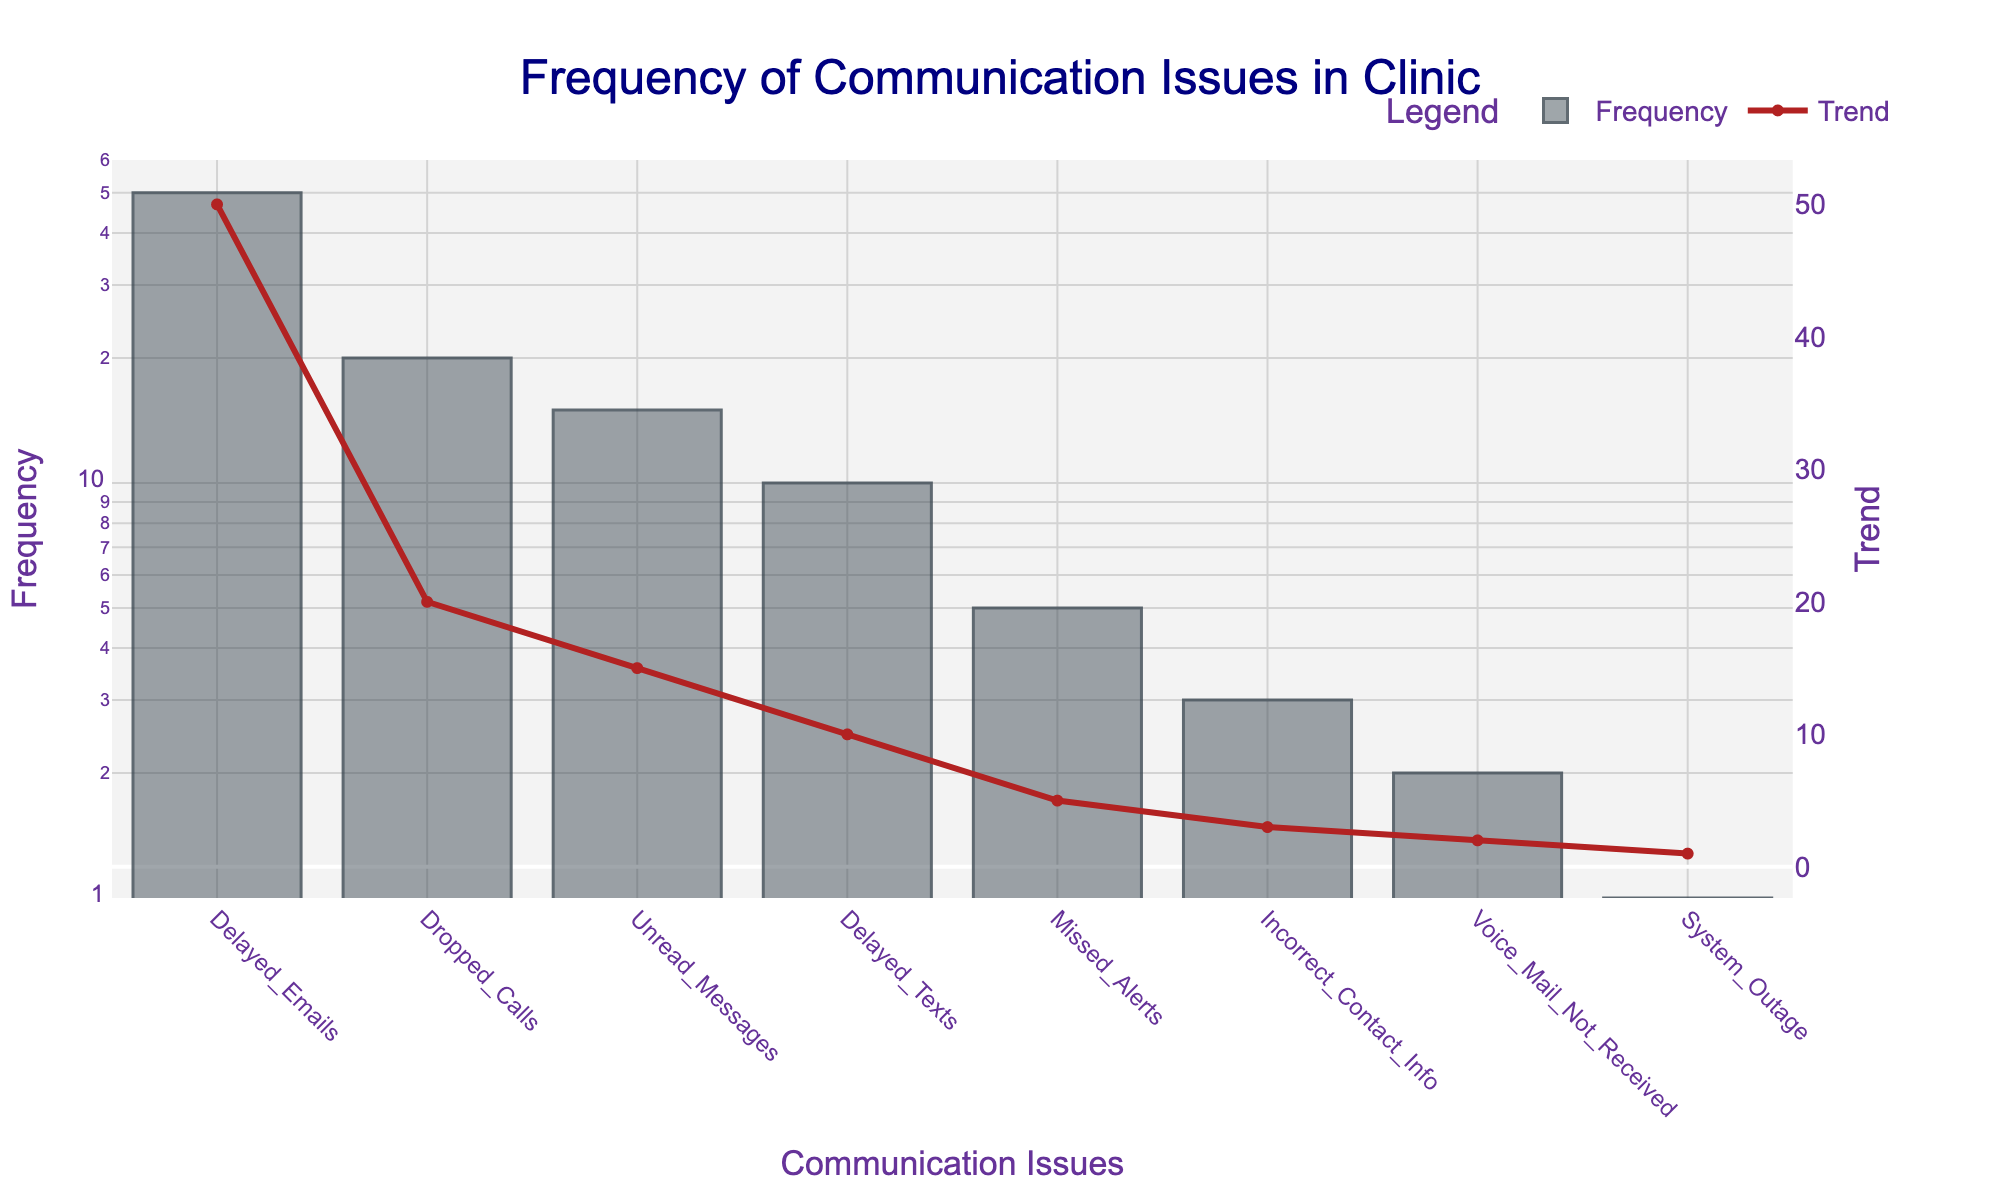What is the title of the plot? The title of a plot is usually found at the top and provides an overview of what the plot represents. In this plot, the title is 'Frequency of Communication Issues in Clinic'.
Answer: Frequency of Communication Issues in Clinic Which communication issue has the highest frequency? To find the communication issue with the highest frequency, look at the bar with the greatest height on the y-axis or the highest value on the line plot. In this plot, 'Delayed Emails' is the highest.
Answer: Delayed Emails What is the frequency of 'Unread Messages'? Locate the bar corresponding to 'Unread Messages' and identify its height on the y-axis. The figure indicates that 'Unread Messages' has a frequency of 15.
Answer: 15 Which communication issue has the lowest frequency, and what is its value? To identify the issue with the lowest frequency, find the smallest bar or the lowest point on the line plot. 'System_Outage' has the lowest frequency, which is 1.
Answer: System_Outage, 1 How many communication issues have a frequency greater than 10? Examine the heights of the bars and count the number of bars with a y-value greater than 10. The issues that meet this criterion are 'Dropped Calls', 'Delayed Emails', and 'Delayed Texts', making a total of 3.
Answer: 3 What is the log scale range of the y-axis? The log scale of the y-axis ranges from 0 to approximately the log of 1.2 times the highest frequency in the data. Here, the highest frequency is 50, so the range is from 0 to about log10(50*1.2). Logarithm of 60 approximately equals 1.78.
Answer: 0 to 1.78 Which communication issue is second most frequent, and what is its frequency? To determine the second most frequent issue, find the second highest bar or point on the line plot. In this plot, 'Dropped Calls' is the second most frequent issue with a frequency of 20.
Answer: Dropped Calls, 20 What is the average frequency of all the communication issues? First, sum up all the frequencies (20 + 50 + 15 + 2 + 3 + 5 + 1 + 10 = 106). Then divide by the number of issues (8). The average frequency is 106/8 = 13.25.
Answer: 13.25 How many issues have a frequency less than 5? Count the bars or points on the line plot with y-values less than 5. These issues are 'Voice Mail Not Received', 'Incorrect Contact Info', 'Missed Alerts', and 'System Outage', making a total of 4.
Answer: 4 Which issue has a greater frequency: 'Missed Alerts' or 'Delayed Texts'? Compare the heights of the bars for 'Missed Alerts' and 'Delayed Texts'. 'Delayed Texts' has a frequency of 10, while 'Missed Alerts' has a frequency of 5, so 'Delayed Texts' has the greater frequency.
Answer: Delayed Texts 